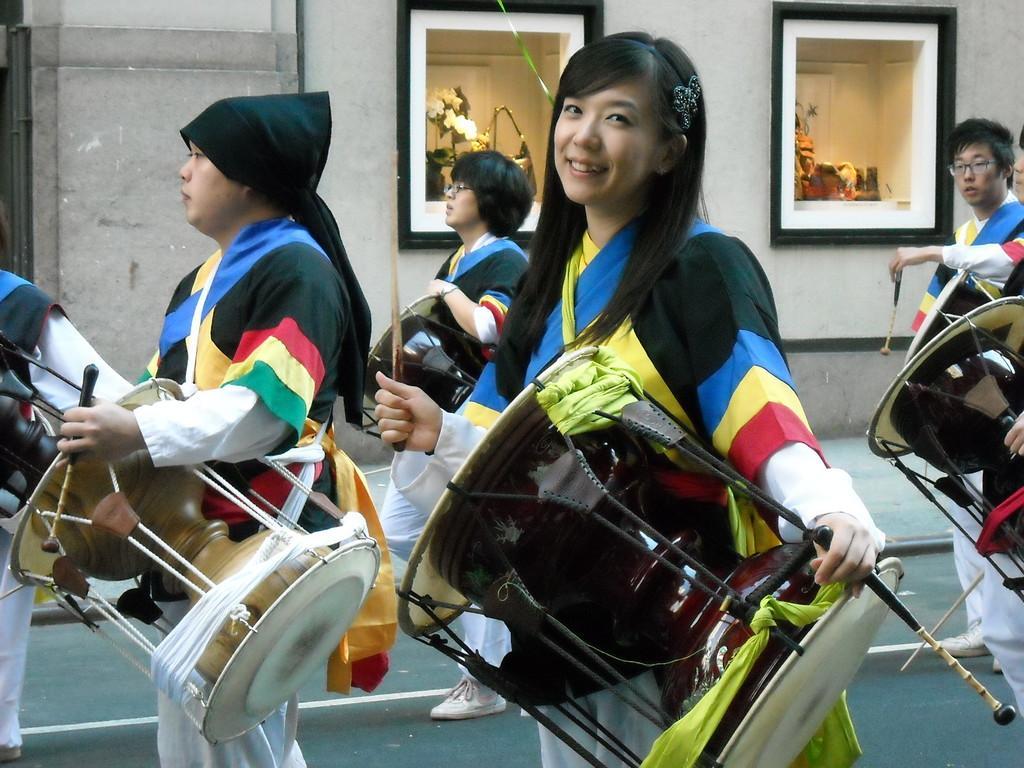Can you describe this image briefly? In this image I can see number of are standing and holding musical instruments. 